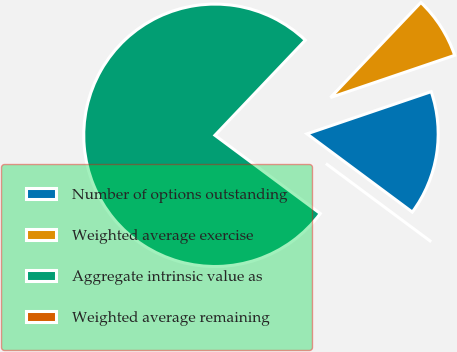Convert chart to OTSL. <chart><loc_0><loc_0><loc_500><loc_500><pie_chart><fcel>Number of options outstanding<fcel>Weighted average exercise<fcel>Aggregate intrinsic value as<fcel>Weighted average remaining<nl><fcel>15.38%<fcel>7.69%<fcel>76.92%<fcel>0.0%<nl></chart> 